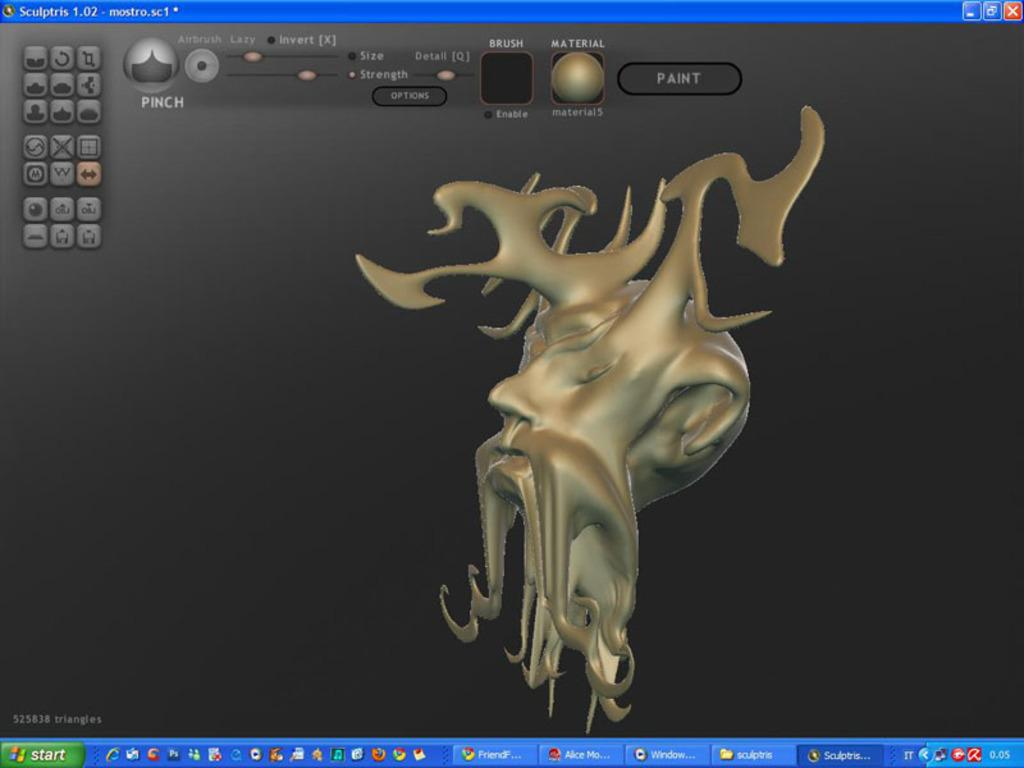Provide a one-sentence caption for the provided image. A screen showing a software creation of strange mythical golden head, has the button 'Paint' above the head. 